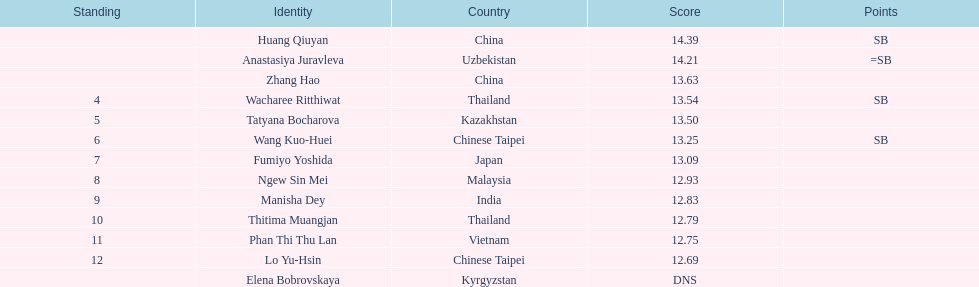How many athletes had a better result than tatyana bocharova? 4. 